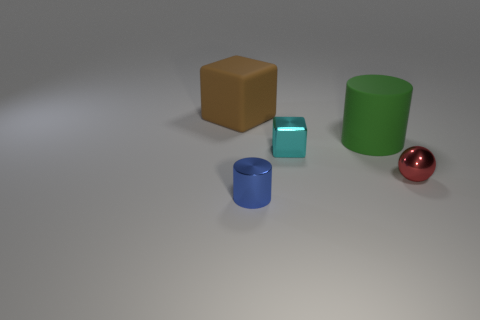Which object stands out the most based on its color? The red sphere stands out the most due to its vibrant color, which contrasts strongly with the more subdued hues of the other objects and the neutral background. 